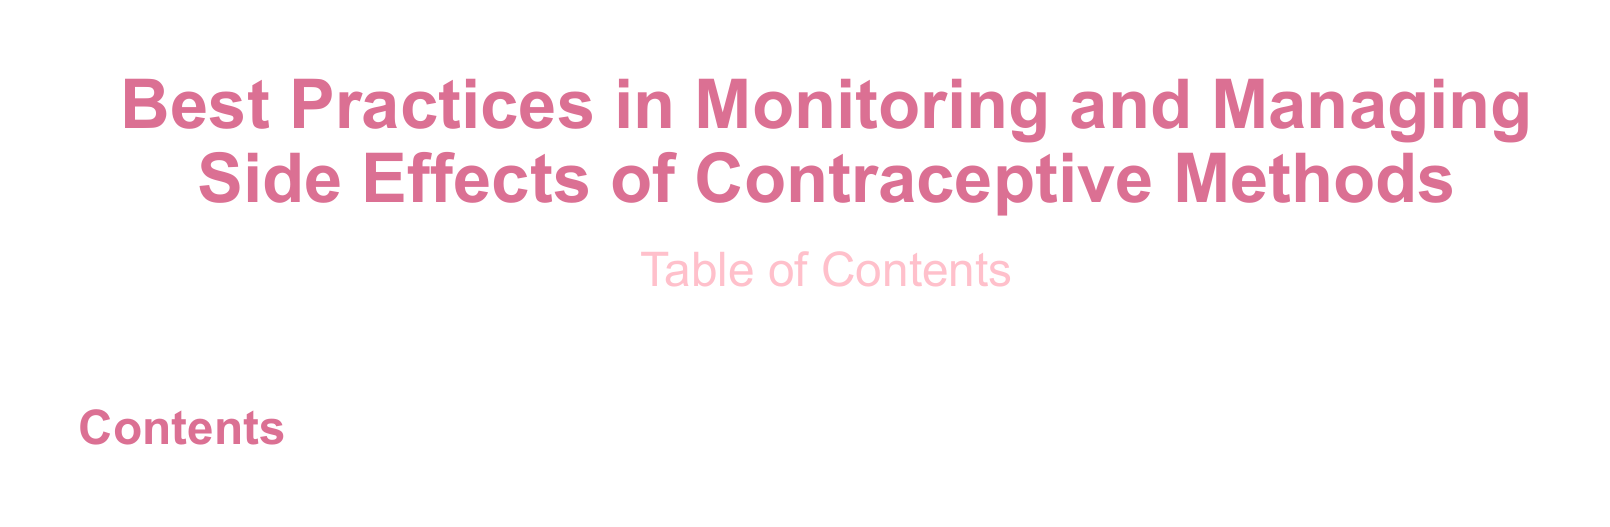What is the document about? The document discusses best practices for monitoring and managing side effects of contraceptive methods.
Answer: Best Practices in Monitoring and Managing Side Effects of Contraceptive Methods What color is used for the main title? The title uses a specific color defined in the document, which is styled to stand out.
Answer: nursedarkpink What is the font used in the document? The document specifies the main font to be used throughout.
Answer: Arial What is included in the Table of Contents? The Table of Contents shows sections and subsections that will be discussed in the document.
Answer: Sections and Subsections What type of document is this? The structure and content indicate the nature of the document.
Answer: Article How many columns are used in the Table of Contents? The document formatting specifies the layout for the Table of Contents.
Answer: Two columns What is the color used for the Table of Contents? The color defined for the Table of Contents enhances its visibility.
Answer: nursepink What is the font size for the main title? The document uses a specific font size for emphasis on the title.
Answer: Huge What visual layout element is used for the title formatting? The titles use a unique formatting style for clarity and emphasis.
Answer: Title format What is the primary audience for this document? The context suggests who the information is intended for.
Answer: Healthcare professionals 